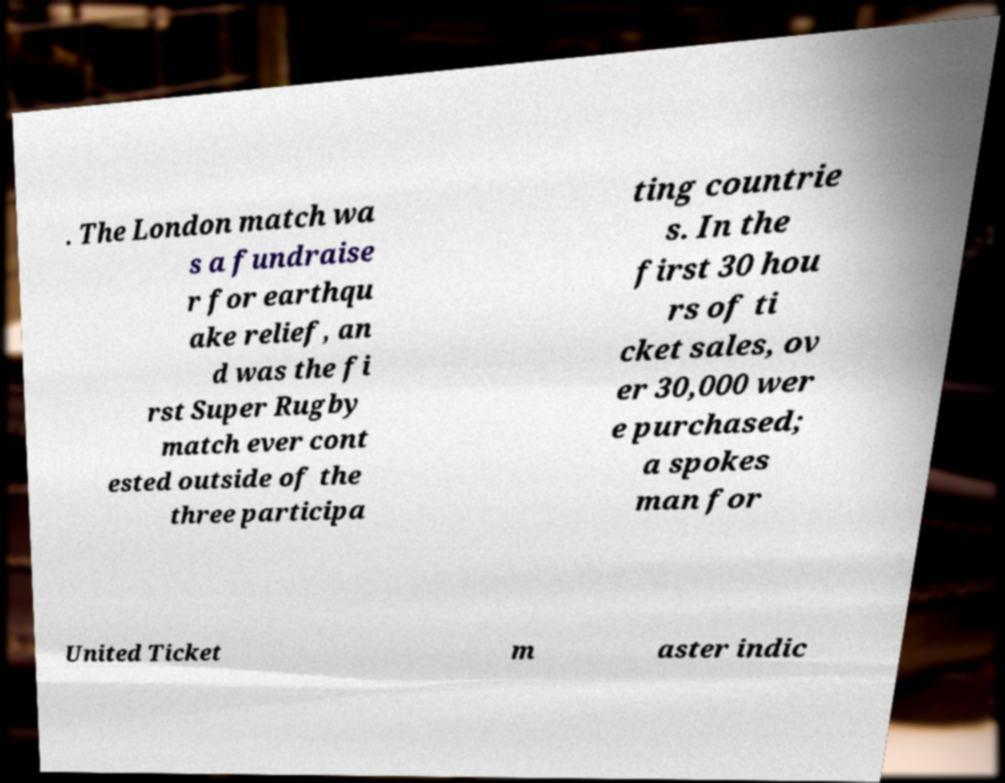Could you extract and type out the text from this image? . The London match wa s a fundraise r for earthqu ake relief, an d was the fi rst Super Rugby match ever cont ested outside of the three participa ting countrie s. In the first 30 hou rs of ti cket sales, ov er 30,000 wer e purchased; a spokes man for United Ticket m aster indic 